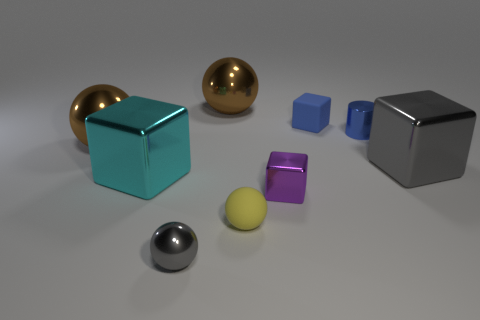There is a gray metallic object that is left of the large shiny ball behind the small blue metallic cylinder; what is its size?
Ensure brevity in your answer.  Small. What number of blocks are cyan metallic things or metallic objects?
Offer a terse response. 3. There is another block that is the same size as the cyan cube; what is its color?
Your response must be concise. Gray. What shape is the large shiny thing in front of the gray thing that is behind the large cyan metallic object?
Ensure brevity in your answer.  Cube. Does the gray thing that is right of the rubber ball have the same size as the tiny shiny cube?
Your answer should be very brief. No. How many other things are made of the same material as the big cyan block?
Give a very brief answer. 6. What number of cyan things are cubes or big shiny balls?
Provide a succinct answer. 1. There is a block that is the same color as the small shiny cylinder; what size is it?
Provide a succinct answer. Small. How many large blocks are left of the tiny yellow matte sphere?
Ensure brevity in your answer.  1. There is a matte object that is to the left of the cube that is behind the cube to the right of the small blue shiny object; how big is it?
Offer a very short reply. Small. 